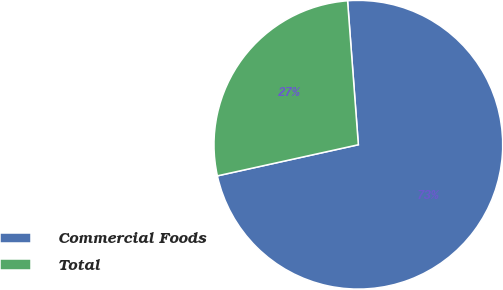Convert chart to OTSL. <chart><loc_0><loc_0><loc_500><loc_500><pie_chart><fcel>Commercial Foods<fcel>Total<nl><fcel>72.73%<fcel>27.27%<nl></chart> 